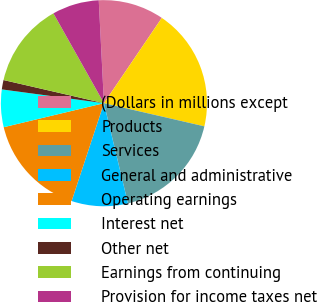Convert chart. <chart><loc_0><loc_0><loc_500><loc_500><pie_chart><fcel>(Dollars in millions except<fcel>Products<fcel>Services<fcel>General and administrative<fcel>Operating earnings<fcel>Interest net<fcel>Other net<fcel>Earnings from continuing<fcel>Provision for income taxes net<nl><fcel>10.29%<fcel>19.12%<fcel>17.65%<fcel>8.82%<fcel>16.18%<fcel>5.88%<fcel>1.47%<fcel>13.24%<fcel>7.35%<nl></chart> 